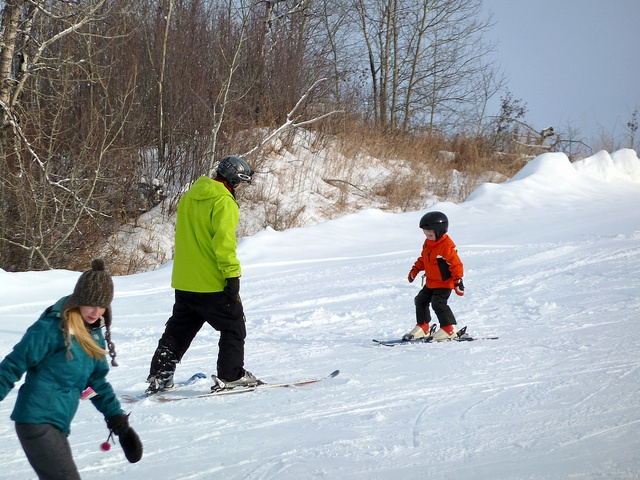Describe the objects in this image and their specific colors. I can see people in darkgray, black, teal, darkblue, and lightgray tones, people in darkgray, black, olive, and lightgray tones, people in darkgray, black, brown, lightgray, and red tones, skis in darkgray, lightgray, and lightblue tones, and skis in darkgray, gray, and lightgray tones in this image. 